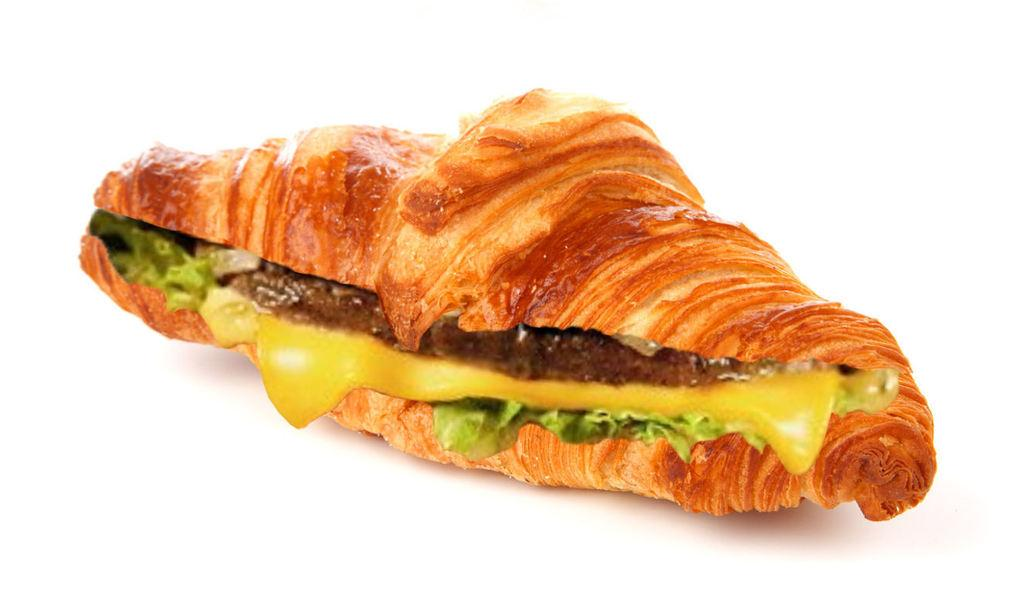What is the main subject of the image? There is a food item arranged on a surface in the image. What can be observed about the background of the image? The background of the image is white in color. What type of bear can be seen interacting with the food item in the image? There is no bear present in the image, and therefore no such interaction can be observed. 